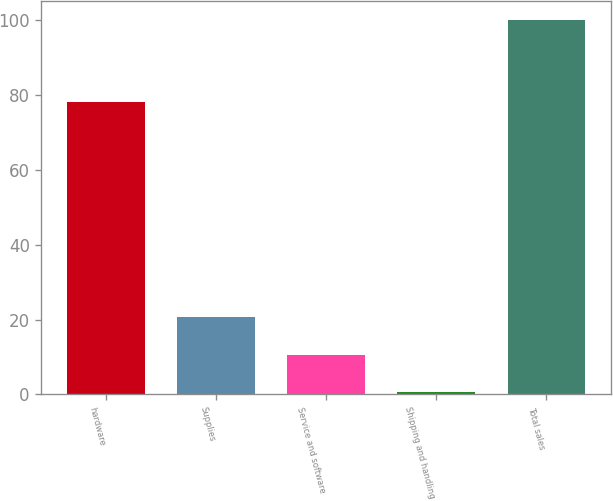Convert chart to OTSL. <chart><loc_0><loc_0><loc_500><loc_500><bar_chart><fcel>hardware<fcel>Supplies<fcel>Service and software<fcel>Shipping and handling<fcel>Total sales<nl><fcel>78.2<fcel>20.56<fcel>10.63<fcel>0.7<fcel>100<nl></chart> 